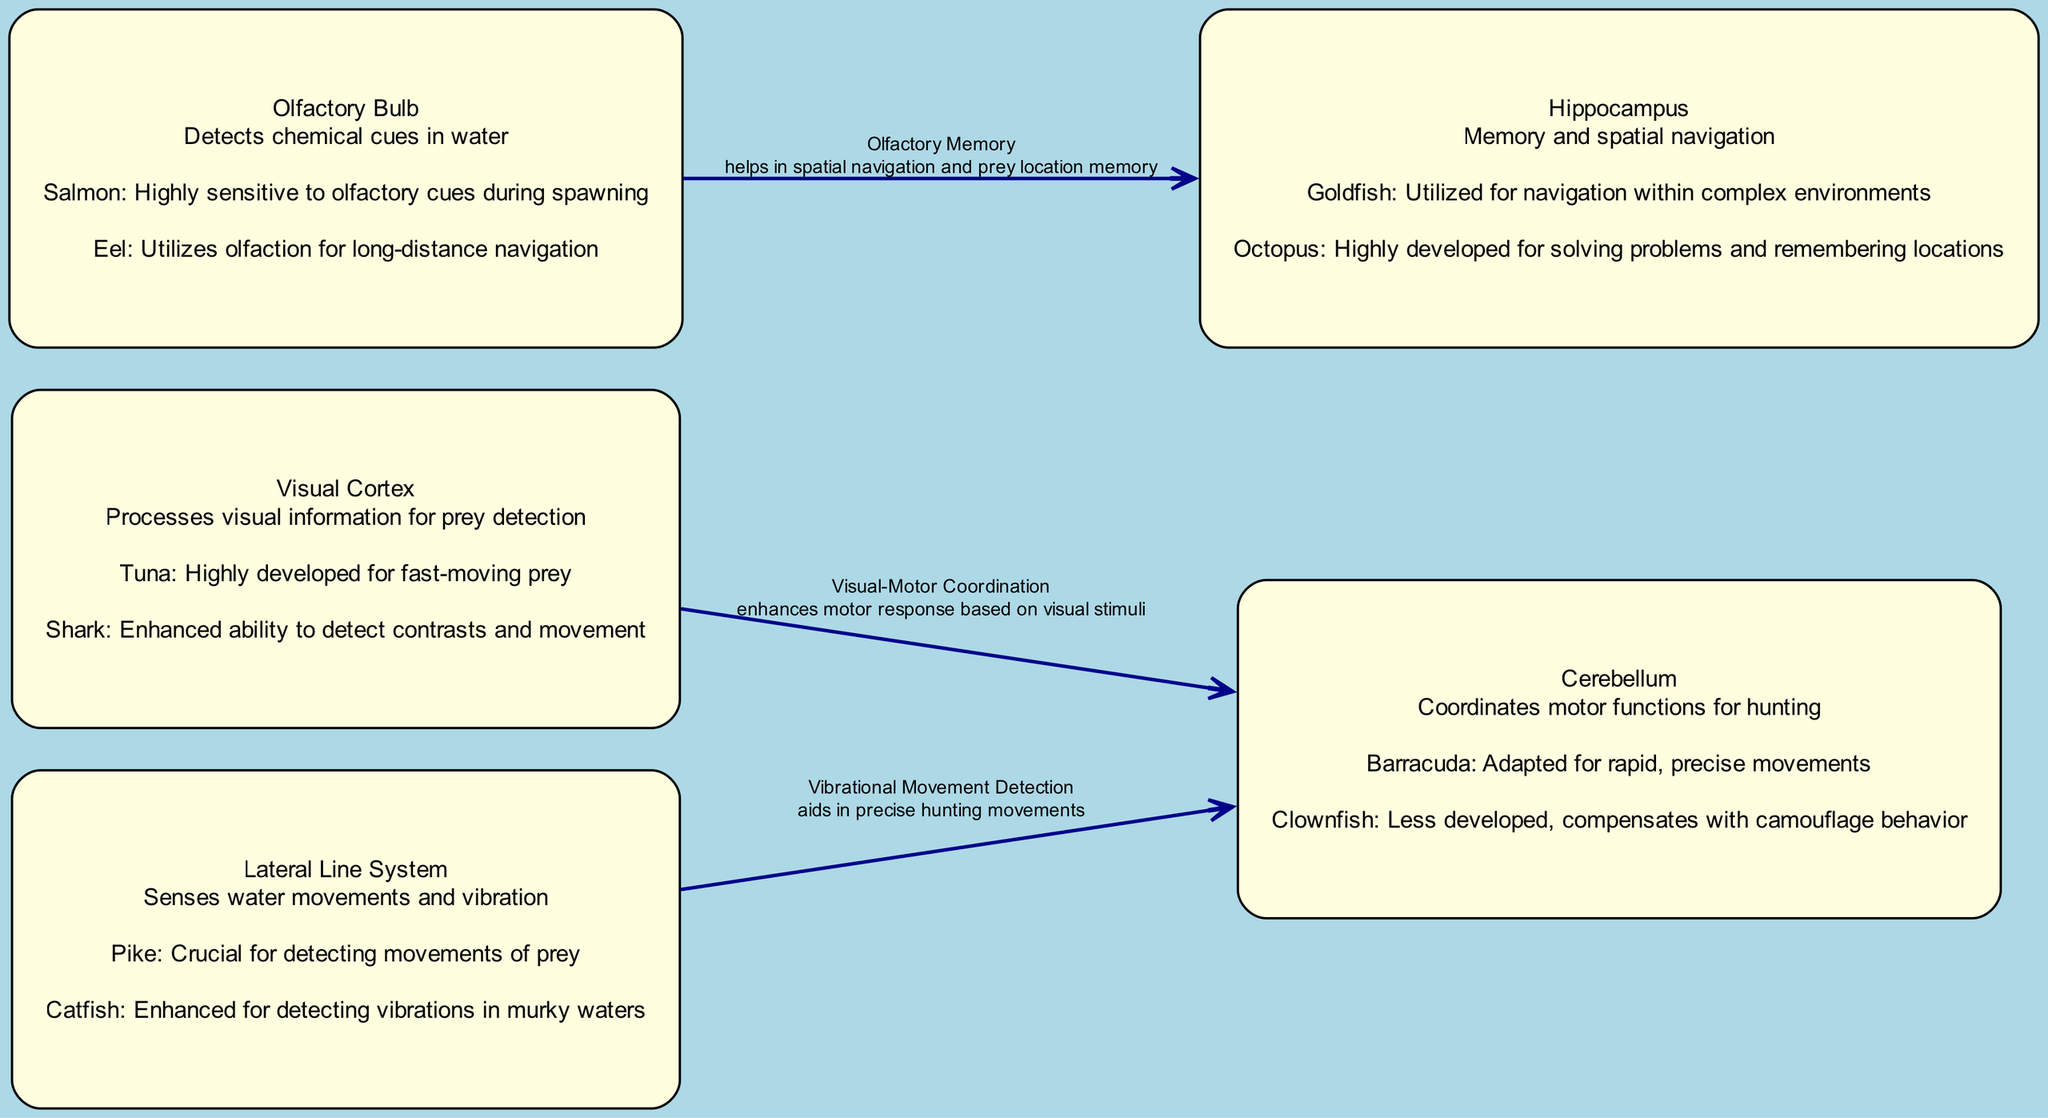What is the total number of nodes in the diagram? The diagram includes a list of nodes, which are: Visual Cortex, Olfactory Bulb, Lateral Line System, Cerebellum, and Hippocampus. Counting these gives a total of five nodes.
Answer: 5 What species is associated with the highest visual cortex development? The Visual Cortex node for Tuna states it is "Highly developed for fast-moving prey." This indicates that Tuna has the highest development in visual processing specifically for this type of prey.
Answer: Tuna Which node has a direct connection with the Olfactory Bulb? The diagram shows an edge from the Olfactory Bulb to the Hippocampus, indicating a direct relationship between these two nodes based on the interaction labeled "Olfactory Memory."
Answer: Hippocampus What interaction type is linked to the edge from the Lateral Line System to the Cerebellum? The edge from the Lateral Line System to the Cerebellum is described with an interaction type that aids in precise hunting movements, specifically denoted as "Vibrational Movement Detection."
Answer: Vibrational Movement Detection Which species uses olfaction for long-distance navigation according to the Olfactory Bulb information? The comparison for the Olfactory Bulb in the context of Eel states that it "Utilizes olfaction for long-distance navigation." This clarifies that the Eel relies on scent signals over larger distances.
Answer: Eel How does the Visual Cortex influence the Cerebellum? The diagram indicates that the connection from the Visual Cortex to the Cerebellum is labeled "Visual-Motor Coordination," highlighting that visual input directly enhances motor responses managed by the Cerebellum.
Answer: Enhances motor response Which species has a less developed cerebellum according to the diagram? The description for Clownfish under the Cerebellum node notes that it is "Less developed, compensates with camouflage behavior." This clearly identifies Clownfish as having a less developed cerebellum relative to others.
Answer: Clownfish What role does the Hippocampus serve in fish hunting behavior? The Hippocampus is labeled as responsible for "Memory and spatial navigation," indicating its vital role in helping fish remember locations of prey and navigate effectively while hunting.
Answer: Memory and spatial navigation 